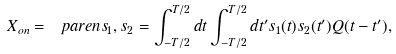<formula> <loc_0><loc_0><loc_500><loc_500>X _ { o n } = \ p a r e n { s _ { 1 } , s _ { 2 } } = \int _ { - T / 2 } ^ { T / 2 } d t \int _ { - T / 2 } ^ { T / 2 } d t ^ { \prime } s _ { 1 } ( t ) s _ { 2 } ( t ^ { \prime } ) Q ( t - t ^ { \prime } ) ,</formula> 